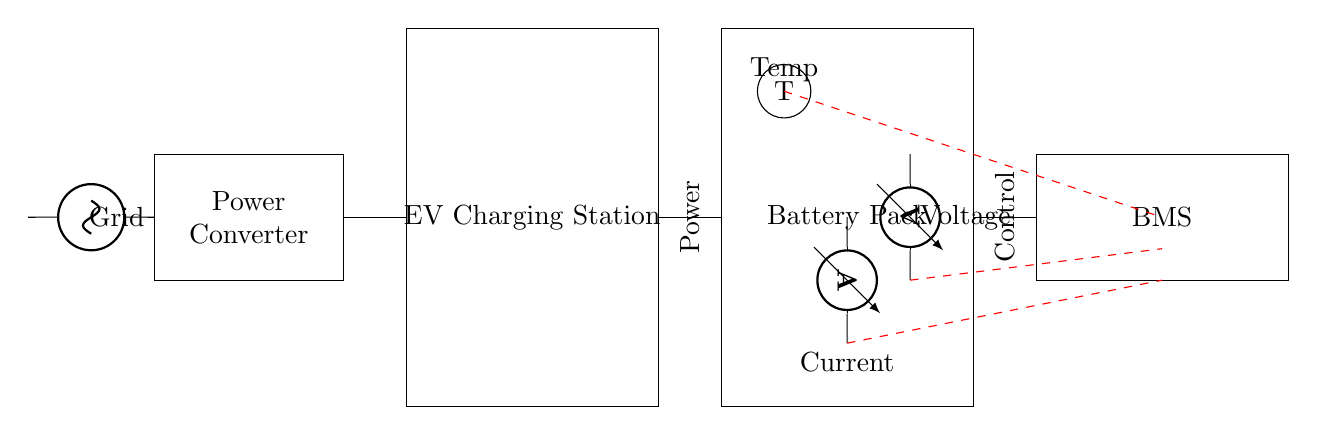What type of appliance is represented in the diagram? The circuit diagram depicts an electric vehicle charging station, as indicated by the labeled rectangle at the top of the diagram.
Answer: Electric vehicle charging station What is inside the Battery Pack? The Battery Pack typically contains multiple battery cells connected in series or parallel, but specific details about the configuration are not provided in the diagram.
Answer: Battery cells What component measures current in this system? The current sensor, denoted by the ammeter symbol in the diagram, is specifically designed to measure the flow of electric current in the circuit.
Answer: Ammeter What type of voltage sensor is shown? The voltage sensor illustrated is a voltmeter, which is used to measure the voltage across two points in the circuit.
Answer: Voltmeter What is the function of the BMS in this circuit? The Battery Management System (BMS) is responsible for monitoring and managing battery performance, ensuring safe charging and discharging, and balancing the battery cells.
Answer: Monitor and manage battery performance How does the communication between sensors and BMS occur? The communication occurs through dashed red lines, indicating that the data from the current sensor, voltage sensor, and temperature sensor is transmitted to the BMS.
Answer: Through communication lines 